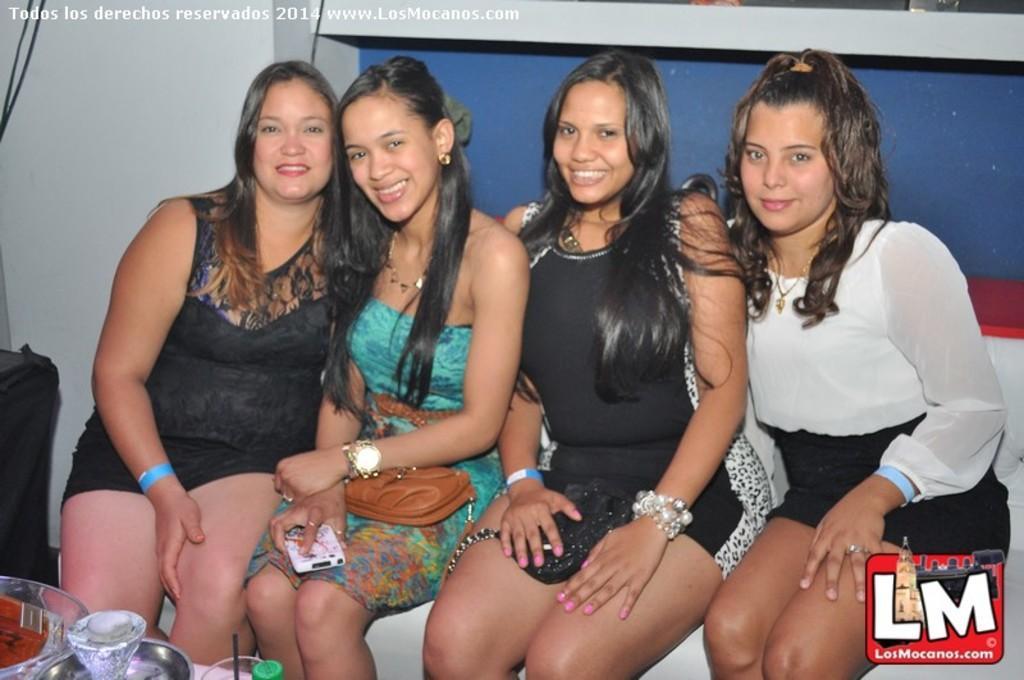Can you describe this image briefly? In this image I can see four people. On the left side I can see some objects on the table. 